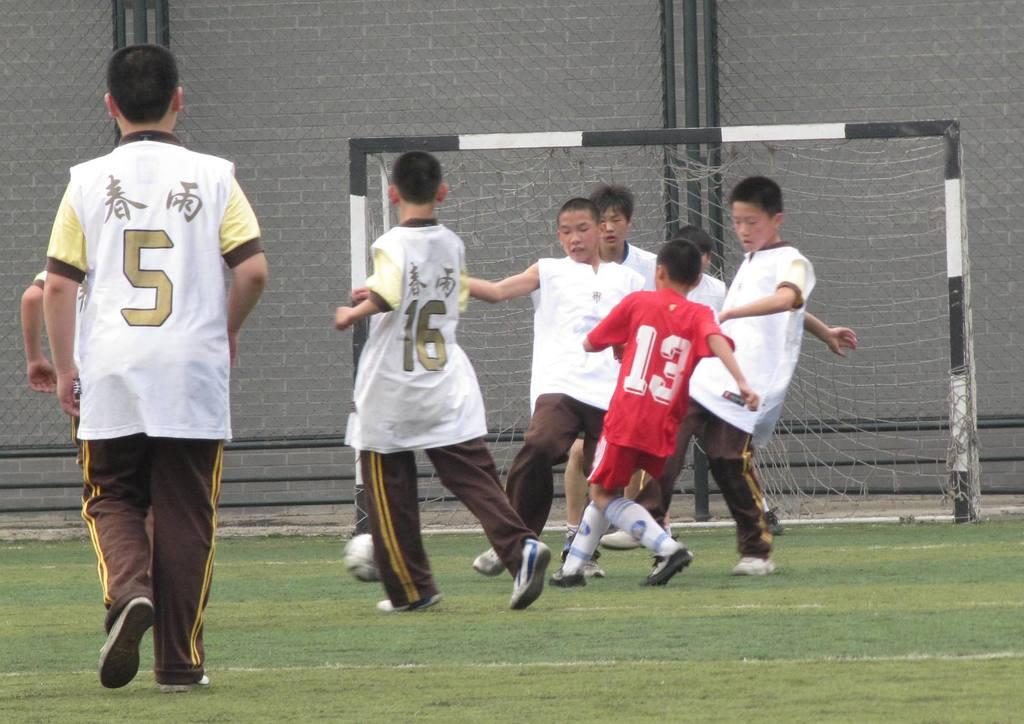What number is the kid in the red jersey?
Provide a succinct answer. 13. The closest kid is wearing what number?
Your answer should be compact. 5. 